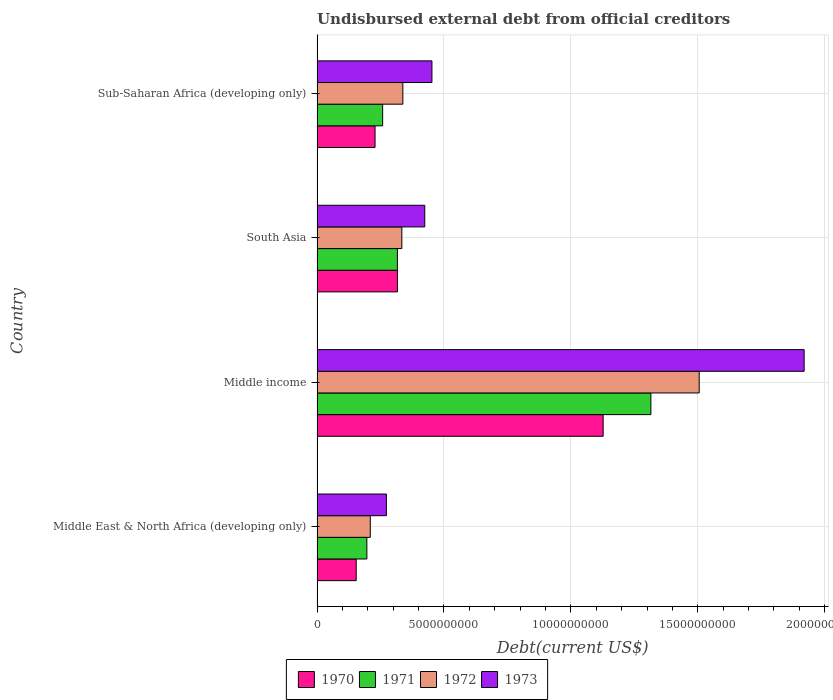How many different coloured bars are there?
Provide a short and direct response. 4. How many groups of bars are there?
Offer a terse response. 4. Are the number of bars on each tick of the Y-axis equal?
Make the answer very short. Yes. How many bars are there on the 1st tick from the top?
Provide a short and direct response. 4. What is the label of the 4th group of bars from the top?
Keep it short and to the point. Middle East & North Africa (developing only). In how many cases, is the number of bars for a given country not equal to the number of legend labels?
Make the answer very short. 0. What is the total debt in 1973 in Middle income?
Make the answer very short. 1.92e+1. Across all countries, what is the maximum total debt in 1970?
Make the answer very short. 1.13e+1. Across all countries, what is the minimum total debt in 1971?
Your answer should be very brief. 1.96e+09. In which country was the total debt in 1973 minimum?
Your answer should be compact. Middle East & North Africa (developing only). What is the total total debt in 1972 in the graph?
Your response must be concise. 2.39e+1. What is the difference between the total debt in 1972 in Middle income and that in South Asia?
Your answer should be compact. 1.17e+1. What is the difference between the total debt in 1972 in South Asia and the total debt in 1973 in Middle East & North Africa (developing only)?
Your response must be concise. 6.09e+08. What is the average total debt in 1972 per country?
Offer a very short reply. 5.97e+09. What is the difference between the total debt in 1972 and total debt in 1970 in Sub-Saharan Africa (developing only)?
Offer a terse response. 1.09e+09. In how many countries, is the total debt in 1973 greater than 7000000000 US$?
Offer a terse response. 1. What is the ratio of the total debt in 1971 in South Asia to that in Sub-Saharan Africa (developing only)?
Offer a terse response. 1.22. Is the difference between the total debt in 1972 in Middle income and Sub-Saharan Africa (developing only) greater than the difference between the total debt in 1970 in Middle income and Sub-Saharan Africa (developing only)?
Offer a very short reply. Yes. What is the difference between the highest and the second highest total debt in 1970?
Provide a succinct answer. 8.10e+09. What is the difference between the highest and the lowest total debt in 1970?
Provide a succinct answer. 9.73e+09. In how many countries, is the total debt in 1971 greater than the average total debt in 1971 taken over all countries?
Ensure brevity in your answer.  1. Is the sum of the total debt in 1971 in South Asia and Sub-Saharan Africa (developing only) greater than the maximum total debt in 1973 across all countries?
Ensure brevity in your answer.  No. How many bars are there?
Ensure brevity in your answer.  16. What is the difference between two consecutive major ticks on the X-axis?
Your answer should be compact. 5.00e+09. Are the values on the major ticks of X-axis written in scientific E-notation?
Your answer should be compact. No. Does the graph contain grids?
Offer a terse response. Yes. What is the title of the graph?
Offer a very short reply. Undisbursed external debt from official creditors. Does "2014" appear as one of the legend labels in the graph?
Your answer should be compact. No. What is the label or title of the X-axis?
Keep it short and to the point. Debt(current US$). What is the Debt(current US$) of 1970 in Middle East & North Africa (developing only)?
Your response must be concise. 1.54e+09. What is the Debt(current US$) in 1971 in Middle East & North Africa (developing only)?
Offer a very short reply. 1.96e+09. What is the Debt(current US$) in 1972 in Middle East & North Africa (developing only)?
Provide a succinct answer. 2.10e+09. What is the Debt(current US$) in 1973 in Middle East & North Africa (developing only)?
Provide a succinct answer. 2.73e+09. What is the Debt(current US$) in 1970 in Middle income?
Your response must be concise. 1.13e+1. What is the Debt(current US$) of 1971 in Middle income?
Your response must be concise. 1.32e+1. What is the Debt(current US$) in 1972 in Middle income?
Make the answer very short. 1.51e+1. What is the Debt(current US$) of 1973 in Middle income?
Ensure brevity in your answer.  1.92e+1. What is the Debt(current US$) of 1970 in South Asia?
Your response must be concise. 3.17e+09. What is the Debt(current US$) of 1971 in South Asia?
Your answer should be very brief. 3.16e+09. What is the Debt(current US$) of 1972 in South Asia?
Your answer should be very brief. 3.34e+09. What is the Debt(current US$) of 1973 in South Asia?
Offer a terse response. 4.24e+09. What is the Debt(current US$) of 1970 in Sub-Saharan Africa (developing only)?
Provide a succinct answer. 2.28e+09. What is the Debt(current US$) of 1971 in Sub-Saharan Africa (developing only)?
Make the answer very short. 2.58e+09. What is the Debt(current US$) in 1972 in Sub-Saharan Africa (developing only)?
Give a very brief answer. 3.38e+09. What is the Debt(current US$) of 1973 in Sub-Saharan Africa (developing only)?
Your answer should be compact. 4.53e+09. Across all countries, what is the maximum Debt(current US$) in 1970?
Provide a succinct answer. 1.13e+1. Across all countries, what is the maximum Debt(current US$) of 1971?
Keep it short and to the point. 1.32e+1. Across all countries, what is the maximum Debt(current US$) of 1972?
Offer a very short reply. 1.51e+1. Across all countries, what is the maximum Debt(current US$) in 1973?
Provide a succinct answer. 1.92e+1. Across all countries, what is the minimum Debt(current US$) in 1970?
Offer a very short reply. 1.54e+09. Across all countries, what is the minimum Debt(current US$) in 1971?
Your response must be concise. 1.96e+09. Across all countries, what is the minimum Debt(current US$) in 1972?
Your answer should be very brief. 2.10e+09. Across all countries, what is the minimum Debt(current US$) in 1973?
Your response must be concise. 2.73e+09. What is the total Debt(current US$) in 1970 in the graph?
Offer a terse response. 1.83e+1. What is the total Debt(current US$) in 1971 in the graph?
Make the answer very short. 2.09e+1. What is the total Debt(current US$) in 1972 in the graph?
Give a very brief answer. 2.39e+1. What is the total Debt(current US$) in 1973 in the graph?
Your response must be concise. 3.07e+1. What is the difference between the Debt(current US$) of 1970 in Middle East & North Africa (developing only) and that in Middle income?
Offer a very short reply. -9.73e+09. What is the difference between the Debt(current US$) of 1971 in Middle East & North Africa (developing only) and that in Middle income?
Provide a short and direct response. -1.12e+1. What is the difference between the Debt(current US$) in 1972 in Middle East & North Africa (developing only) and that in Middle income?
Provide a succinct answer. -1.30e+1. What is the difference between the Debt(current US$) of 1973 in Middle East & North Africa (developing only) and that in Middle income?
Provide a short and direct response. -1.65e+1. What is the difference between the Debt(current US$) in 1970 in Middle East & North Africa (developing only) and that in South Asia?
Offer a very short reply. -1.62e+09. What is the difference between the Debt(current US$) of 1971 in Middle East & North Africa (developing only) and that in South Asia?
Provide a short and direct response. -1.20e+09. What is the difference between the Debt(current US$) of 1972 in Middle East & North Africa (developing only) and that in South Asia?
Give a very brief answer. -1.24e+09. What is the difference between the Debt(current US$) in 1973 in Middle East & North Africa (developing only) and that in South Asia?
Provide a short and direct response. -1.51e+09. What is the difference between the Debt(current US$) in 1970 in Middle East & North Africa (developing only) and that in Sub-Saharan Africa (developing only)?
Provide a short and direct response. -7.42e+08. What is the difference between the Debt(current US$) of 1971 in Middle East & North Africa (developing only) and that in Sub-Saharan Africa (developing only)?
Offer a very short reply. -6.22e+08. What is the difference between the Debt(current US$) of 1972 in Middle East & North Africa (developing only) and that in Sub-Saharan Africa (developing only)?
Offer a very short reply. -1.28e+09. What is the difference between the Debt(current US$) of 1973 in Middle East & North Africa (developing only) and that in Sub-Saharan Africa (developing only)?
Offer a terse response. -1.79e+09. What is the difference between the Debt(current US$) of 1970 in Middle income and that in South Asia?
Make the answer very short. 8.10e+09. What is the difference between the Debt(current US$) of 1971 in Middle income and that in South Asia?
Offer a terse response. 9.99e+09. What is the difference between the Debt(current US$) in 1972 in Middle income and that in South Asia?
Your answer should be very brief. 1.17e+1. What is the difference between the Debt(current US$) in 1973 in Middle income and that in South Asia?
Ensure brevity in your answer.  1.49e+1. What is the difference between the Debt(current US$) of 1970 in Middle income and that in Sub-Saharan Africa (developing only)?
Give a very brief answer. 8.99e+09. What is the difference between the Debt(current US$) of 1971 in Middle income and that in Sub-Saharan Africa (developing only)?
Make the answer very short. 1.06e+1. What is the difference between the Debt(current US$) of 1972 in Middle income and that in Sub-Saharan Africa (developing only)?
Offer a very short reply. 1.17e+1. What is the difference between the Debt(current US$) of 1973 in Middle income and that in Sub-Saharan Africa (developing only)?
Your answer should be very brief. 1.47e+1. What is the difference between the Debt(current US$) in 1970 in South Asia and that in Sub-Saharan Africa (developing only)?
Provide a short and direct response. 8.81e+08. What is the difference between the Debt(current US$) of 1971 in South Asia and that in Sub-Saharan Africa (developing only)?
Your answer should be compact. 5.81e+08. What is the difference between the Debt(current US$) of 1972 in South Asia and that in Sub-Saharan Africa (developing only)?
Offer a very short reply. -3.94e+07. What is the difference between the Debt(current US$) in 1973 in South Asia and that in Sub-Saharan Africa (developing only)?
Your answer should be compact. -2.82e+08. What is the difference between the Debt(current US$) of 1970 in Middle East & North Africa (developing only) and the Debt(current US$) of 1971 in Middle income?
Offer a very short reply. -1.16e+1. What is the difference between the Debt(current US$) in 1970 in Middle East & North Africa (developing only) and the Debt(current US$) in 1972 in Middle income?
Your answer should be compact. -1.35e+1. What is the difference between the Debt(current US$) in 1970 in Middle East & North Africa (developing only) and the Debt(current US$) in 1973 in Middle income?
Provide a short and direct response. -1.76e+1. What is the difference between the Debt(current US$) of 1971 in Middle East & North Africa (developing only) and the Debt(current US$) of 1972 in Middle income?
Your answer should be compact. -1.31e+1. What is the difference between the Debt(current US$) of 1971 in Middle East & North Africa (developing only) and the Debt(current US$) of 1973 in Middle income?
Ensure brevity in your answer.  -1.72e+1. What is the difference between the Debt(current US$) in 1972 in Middle East & North Africa (developing only) and the Debt(current US$) in 1973 in Middle income?
Offer a very short reply. -1.71e+1. What is the difference between the Debt(current US$) of 1970 in Middle East & North Africa (developing only) and the Debt(current US$) of 1971 in South Asia?
Give a very brief answer. -1.62e+09. What is the difference between the Debt(current US$) in 1970 in Middle East & North Africa (developing only) and the Debt(current US$) in 1972 in South Asia?
Ensure brevity in your answer.  -1.80e+09. What is the difference between the Debt(current US$) in 1970 in Middle East & North Africa (developing only) and the Debt(current US$) in 1973 in South Asia?
Make the answer very short. -2.70e+09. What is the difference between the Debt(current US$) of 1971 in Middle East & North Africa (developing only) and the Debt(current US$) of 1972 in South Asia?
Provide a short and direct response. -1.38e+09. What is the difference between the Debt(current US$) of 1971 in Middle East & North Africa (developing only) and the Debt(current US$) of 1973 in South Asia?
Give a very brief answer. -2.28e+09. What is the difference between the Debt(current US$) of 1972 in Middle East & North Africa (developing only) and the Debt(current US$) of 1973 in South Asia?
Provide a succinct answer. -2.15e+09. What is the difference between the Debt(current US$) of 1970 in Middle East & North Africa (developing only) and the Debt(current US$) of 1971 in Sub-Saharan Africa (developing only)?
Keep it short and to the point. -1.04e+09. What is the difference between the Debt(current US$) in 1970 in Middle East & North Africa (developing only) and the Debt(current US$) in 1972 in Sub-Saharan Africa (developing only)?
Offer a terse response. -1.84e+09. What is the difference between the Debt(current US$) of 1970 in Middle East & North Africa (developing only) and the Debt(current US$) of 1973 in Sub-Saharan Africa (developing only)?
Your response must be concise. -2.98e+09. What is the difference between the Debt(current US$) in 1971 in Middle East & North Africa (developing only) and the Debt(current US$) in 1972 in Sub-Saharan Africa (developing only)?
Offer a terse response. -1.42e+09. What is the difference between the Debt(current US$) of 1971 in Middle East & North Africa (developing only) and the Debt(current US$) of 1973 in Sub-Saharan Africa (developing only)?
Offer a terse response. -2.56e+09. What is the difference between the Debt(current US$) in 1972 in Middle East & North Africa (developing only) and the Debt(current US$) in 1973 in Sub-Saharan Africa (developing only)?
Your answer should be very brief. -2.43e+09. What is the difference between the Debt(current US$) in 1970 in Middle income and the Debt(current US$) in 1971 in South Asia?
Your response must be concise. 8.11e+09. What is the difference between the Debt(current US$) of 1970 in Middle income and the Debt(current US$) of 1972 in South Asia?
Ensure brevity in your answer.  7.93e+09. What is the difference between the Debt(current US$) in 1970 in Middle income and the Debt(current US$) in 1973 in South Asia?
Provide a short and direct response. 7.03e+09. What is the difference between the Debt(current US$) in 1971 in Middle income and the Debt(current US$) in 1972 in South Asia?
Keep it short and to the point. 9.81e+09. What is the difference between the Debt(current US$) in 1971 in Middle income and the Debt(current US$) in 1973 in South Asia?
Offer a terse response. 8.91e+09. What is the difference between the Debt(current US$) of 1972 in Middle income and the Debt(current US$) of 1973 in South Asia?
Your answer should be compact. 1.08e+1. What is the difference between the Debt(current US$) of 1970 in Middle income and the Debt(current US$) of 1971 in Sub-Saharan Africa (developing only)?
Offer a very short reply. 8.69e+09. What is the difference between the Debt(current US$) of 1970 in Middle income and the Debt(current US$) of 1972 in Sub-Saharan Africa (developing only)?
Provide a short and direct response. 7.89e+09. What is the difference between the Debt(current US$) in 1970 in Middle income and the Debt(current US$) in 1973 in Sub-Saharan Africa (developing only)?
Provide a succinct answer. 6.75e+09. What is the difference between the Debt(current US$) of 1971 in Middle income and the Debt(current US$) of 1972 in Sub-Saharan Africa (developing only)?
Your response must be concise. 9.77e+09. What is the difference between the Debt(current US$) in 1971 in Middle income and the Debt(current US$) in 1973 in Sub-Saharan Africa (developing only)?
Provide a succinct answer. 8.62e+09. What is the difference between the Debt(current US$) in 1972 in Middle income and the Debt(current US$) in 1973 in Sub-Saharan Africa (developing only)?
Give a very brief answer. 1.05e+1. What is the difference between the Debt(current US$) in 1970 in South Asia and the Debt(current US$) in 1971 in Sub-Saharan Africa (developing only)?
Give a very brief answer. 5.82e+08. What is the difference between the Debt(current US$) in 1970 in South Asia and the Debt(current US$) in 1972 in Sub-Saharan Africa (developing only)?
Give a very brief answer. -2.14e+08. What is the difference between the Debt(current US$) in 1970 in South Asia and the Debt(current US$) in 1973 in Sub-Saharan Africa (developing only)?
Provide a short and direct response. -1.36e+09. What is the difference between the Debt(current US$) in 1971 in South Asia and the Debt(current US$) in 1972 in Sub-Saharan Africa (developing only)?
Your answer should be very brief. -2.15e+08. What is the difference between the Debt(current US$) of 1971 in South Asia and the Debt(current US$) of 1973 in Sub-Saharan Africa (developing only)?
Keep it short and to the point. -1.36e+09. What is the difference between the Debt(current US$) in 1972 in South Asia and the Debt(current US$) in 1973 in Sub-Saharan Africa (developing only)?
Offer a terse response. -1.19e+09. What is the average Debt(current US$) in 1970 per country?
Your answer should be very brief. 4.57e+09. What is the average Debt(current US$) of 1971 per country?
Give a very brief answer. 5.22e+09. What is the average Debt(current US$) in 1972 per country?
Ensure brevity in your answer.  5.97e+09. What is the average Debt(current US$) of 1973 per country?
Provide a short and direct response. 7.67e+09. What is the difference between the Debt(current US$) of 1970 and Debt(current US$) of 1971 in Middle East & North Africa (developing only)?
Your response must be concise. -4.19e+08. What is the difference between the Debt(current US$) in 1970 and Debt(current US$) in 1972 in Middle East & North Africa (developing only)?
Offer a very short reply. -5.55e+08. What is the difference between the Debt(current US$) in 1970 and Debt(current US$) in 1973 in Middle East & North Africa (developing only)?
Keep it short and to the point. -1.19e+09. What is the difference between the Debt(current US$) of 1971 and Debt(current US$) of 1972 in Middle East & North Africa (developing only)?
Keep it short and to the point. -1.35e+08. What is the difference between the Debt(current US$) in 1971 and Debt(current US$) in 1973 in Middle East & North Africa (developing only)?
Keep it short and to the point. -7.70e+08. What is the difference between the Debt(current US$) in 1972 and Debt(current US$) in 1973 in Middle East & North Africa (developing only)?
Your response must be concise. -6.34e+08. What is the difference between the Debt(current US$) of 1970 and Debt(current US$) of 1971 in Middle income?
Give a very brief answer. -1.88e+09. What is the difference between the Debt(current US$) in 1970 and Debt(current US$) in 1972 in Middle income?
Make the answer very short. -3.78e+09. What is the difference between the Debt(current US$) in 1970 and Debt(current US$) in 1973 in Middle income?
Ensure brevity in your answer.  -7.92e+09. What is the difference between the Debt(current US$) in 1971 and Debt(current US$) in 1972 in Middle income?
Offer a terse response. -1.90e+09. What is the difference between the Debt(current US$) in 1971 and Debt(current US$) in 1973 in Middle income?
Your answer should be very brief. -6.04e+09. What is the difference between the Debt(current US$) of 1972 and Debt(current US$) of 1973 in Middle income?
Ensure brevity in your answer.  -4.13e+09. What is the difference between the Debt(current US$) in 1970 and Debt(current US$) in 1971 in South Asia?
Offer a terse response. 1.31e+06. What is the difference between the Debt(current US$) in 1970 and Debt(current US$) in 1972 in South Asia?
Your answer should be very brief. -1.74e+08. What is the difference between the Debt(current US$) in 1970 and Debt(current US$) in 1973 in South Asia?
Give a very brief answer. -1.08e+09. What is the difference between the Debt(current US$) of 1971 and Debt(current US$) of 1972 in South Asia?
Ensure brevity in your answer.  -1.76e+08. What is the difference between the Debt(current US$) in 1971 and Debt(current US$) in 1973 in South Asia?
Your response must be concise. -1.08e+09. What is the difference between the Debt(current US$) of 1972 and Debt(current US$) of 1973 in South Asia?
Offer a very short reply. -9.03e+08. What is the difference between the Debt(current US$) in 1970 and Debt(current US$) in 1971 in Sub-Saharan Africa (developing only)?
Give a very brief answer. -2.99e+08. What is the difference between the Debt(current US$) of 1970 and Debt(current US$) of 1972 in Sub-Saharan Africa (developing only)?
Provide a short and direct response. -1.09e+09. What is the difference between the Debt(current US$) in 1970 and Debt(current US$) in 1973 in Sub-Saharan Africa (developing only)?
Your answer should be compact. -2.24e+09. What is the difference between the Debt(current US$) in 1971 and Debt(current US$) in 1972 in Sub-Saharan Africa (developing only)?
Provide a succinct answer. -7.96e+08. What is the difference between the Debt(current US$) in 1971 and Debt(current US$) in 1973 in Sub-Saharan Africa (developing only)?
Make the answer very short. -1.94e+09. What is the difference between the Debt(current US$) in 1972 and Debt(current US$) in 1973 in Sub-Saharan Africa (developing only)?
Offer a very short reply. -1.15e+09. What is the ratio of the Debt(current US$) of 1970 in Middle East & North Africa (developing only) to that in Middle income?
Provide a short and direct response. 0.14. What is the ratio of the Debt(current US$) of 1971 in Middle East & North Africa (developing only) to that in Middle income?
Keep it short and to the point. 0.15. What is the ratio of the Debt(current US$) in 1972 in Middle East & North Africa (developing only) to that in Middle income?
Offer a terse response. 0.14. What is the ratio of the Debt(current US$) in 1973 in Middle East & North Africa (developing only) to that in Middle income?
Provide a short and direct response. 0.14. What is the ratio of the Debt(current US$) of 1970 in Middle East & North Africa (developing only) to that in South Asia?
Keep it short and to the point. 0.49. What is the ratio of the Debt(current US$) in 1971 in Middle East & North Africa (developing only) to that in South Asia?
Your answer should be very brief. 0.62. What is the ratio of the Debt(current US$) of 1972 in Middle East & North Africa (developing only) to that in South Asia?
Keep it short and to the point. 0.63. What is the ratio of the Debt(current US$) of 1973 in Middle East & North Africa (developing only) to that in South Asia?
Provide a short and direct response. 0.64. What is the ratio of the Debt(current US$) of 1970 in Middle East & North Africa (developing only) to that in Sub-Saharan Africa (developing only)?
Your answer should be very brief. 0.68. What is the ratio of the Debt(current US$) of 1971 in Middle East & North Africa (developing only) to that in Sub-Saharan Africa (developing only)?
Keep it short and to the point. 0.76. What is the ratio of the Debt(current US$) of 1972 in Middle East & North Africa (developing only) to that in Sub-Saharan Africa (developing only)?
Provide a succinct answer. 0.62. What is the ratio of the Debt(current US$) of 1973 in Middle East & North Africa (developing only) to that in Sub-Saharan Africa (developing only)?
Keep it short and to the point. 0.6. What is the ratio of the Debt(current US$) in 1970 in Middle income to that in South Asia?
Keep it short and to the point. 3.56. What is the ratio of the Debt(current US$) of 1971 in Middle income to that in South Asia?
Your answer should be compact. 4.16. What is the ratio of the Debt(current US$) of 1972 in Middle income to that in South Asia?
Provide a short and direct response. 4.51. What is the ratio of the Debt(current US$) of 1973 in Middle income to that in South Asia?
Your answer should be very brief. 4.52. What is the ratio of the Debt(current US$) in 1970 in Middle income to that in Sub-Saharan Africa (developing only)?
Your answer should be compact. 4.93. What is the ratio of the Debt(current US$) of 1971 in Middle income to that in Sub-Saharan Africa (developing only)?
Keep it short and to the point. 5.09. What is the ratio of the Debt(current US$) of 1972 in Middle income to that in Sub-Saharan Africa (developing only)?
Offer a very short reply. 4.45. What is the ratio of the Debt(current US$) of 1973 in Middle income to that in Sub-Saharan Africa (developing only)?
Keep it short and to the point. 4.24. What is the ratio of the Debt(current US$) of 1970 in South Asia to that in Sub-Saharan Africa (developing only)?
Provide a short and direct response. 1.39. What is the ratio of the Debt(current US$) in 1971 in South Asia to that in Sub-Saharan Africa (developing only)?
Your answer should be very brief. 1.22. What is the ratio of the Debt(current US$) in 1972 in South Asia to that in Sub-Saharan Africa (developing only)?
Keep it short and to the point. 0.99. What is the ratio of the Debt(current US$) in 1973 in South Asia to that in Sub-Saharan Africa (developing only)?
Your answer should be very brief. 0.94. What is the difference between the highest and the second highest Debt(current US$) in 1970?
Ensure brevity in your answer.  8.10e+09. What is the difference between the highest and the second highest Debt(current US$) of 1971?
Give a very brief answer. 9.99e+09. What is the difference between the highest and the second highest Debt(current US$) of 1972?
Provide a short and direct response. 1.17e+1. What is the difference between the highest and the second highest Debt(current US$) in 1973?
Make the answer very short. 1.47e+1. What is the difference between the highest and the lowest Debt(current US$) in 1970?
Your answer should be compact. 9.73e+09. What is the difference between the highest and the lowest Debt(current US$) of 1971?
Keep it short and to the point. 1.12e+1. What is the difference between the highest and the lowest Debt(current US$) in 1972?
Provide a succinct answer. 1.30e+1. What is the difference between the highest and the lowest Debt(current US$) in 1973?
Your response must be concise. 1.65e+1. 